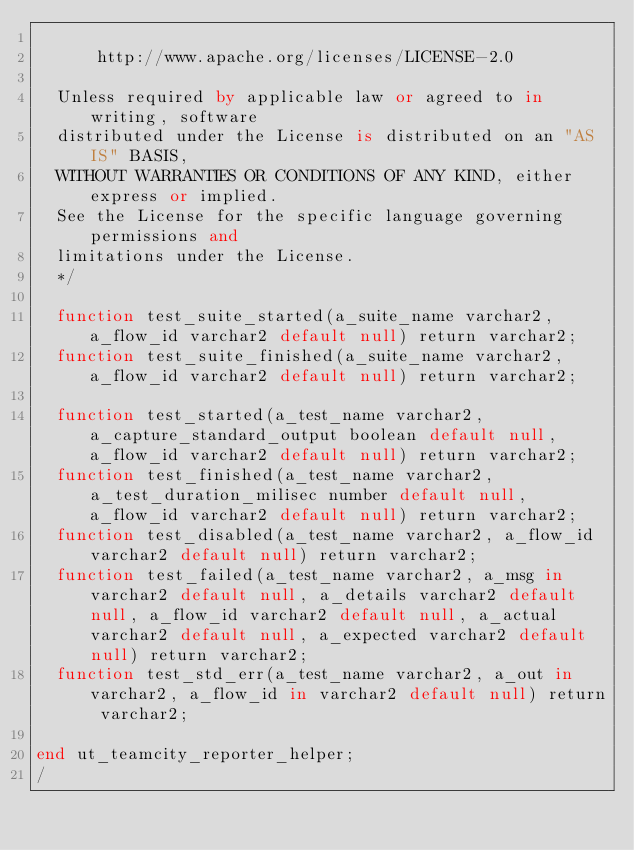Convert code to text. <code><loc_0><loc_0><loc_500><loc_500><_SQL_>
      http://www.apache.org/licenses/LICENSE-2.0

  Unless required by applicable law or agreed to in writing, software
  distributed under the License is distributed on an "AS IS" BASIS,
  WITHOUT WARRANTIES OR CONDITIONS OF ANY KIND, either express or implied.
  See the License for the specific language governing permissions and
  limitations under the License.
  */

  function test_suite_started(a_suite_name varchar2, a_flow_id varchar2 default null) return varchar2;
  function test_suite_finished(a_suite_name varchar2, a_flow_id varchar2 default null) return varchar2;

  function test_started(a_test_name varchar2, a_capture_standard_output boolean default null, a_flow_id varchar2 default null) return varchar2;
  function test_finished(a_test_name varchar2, a_test_duration_milisec number default null, a_flow_id varchar2 default null) return varchar2;
  function test_disabled(a_test_name varchar2, a_flow_id varchar2 default null) return varchar2;
  function test_failed(a_test_name varchar2, a_msg in varchar2 default null, a_details varchar2 default null, a_flow_id varchar2 default null, a_actual varchar2 default null, a_expected varchar2 default null) return varchar2;
  function test_std_err(a_test_name varchar2, a_out in varchar2, a_flow_id in varchar2 default null) return varchar2;

end ut_teamcity_reporter_helper;
/
</code> 